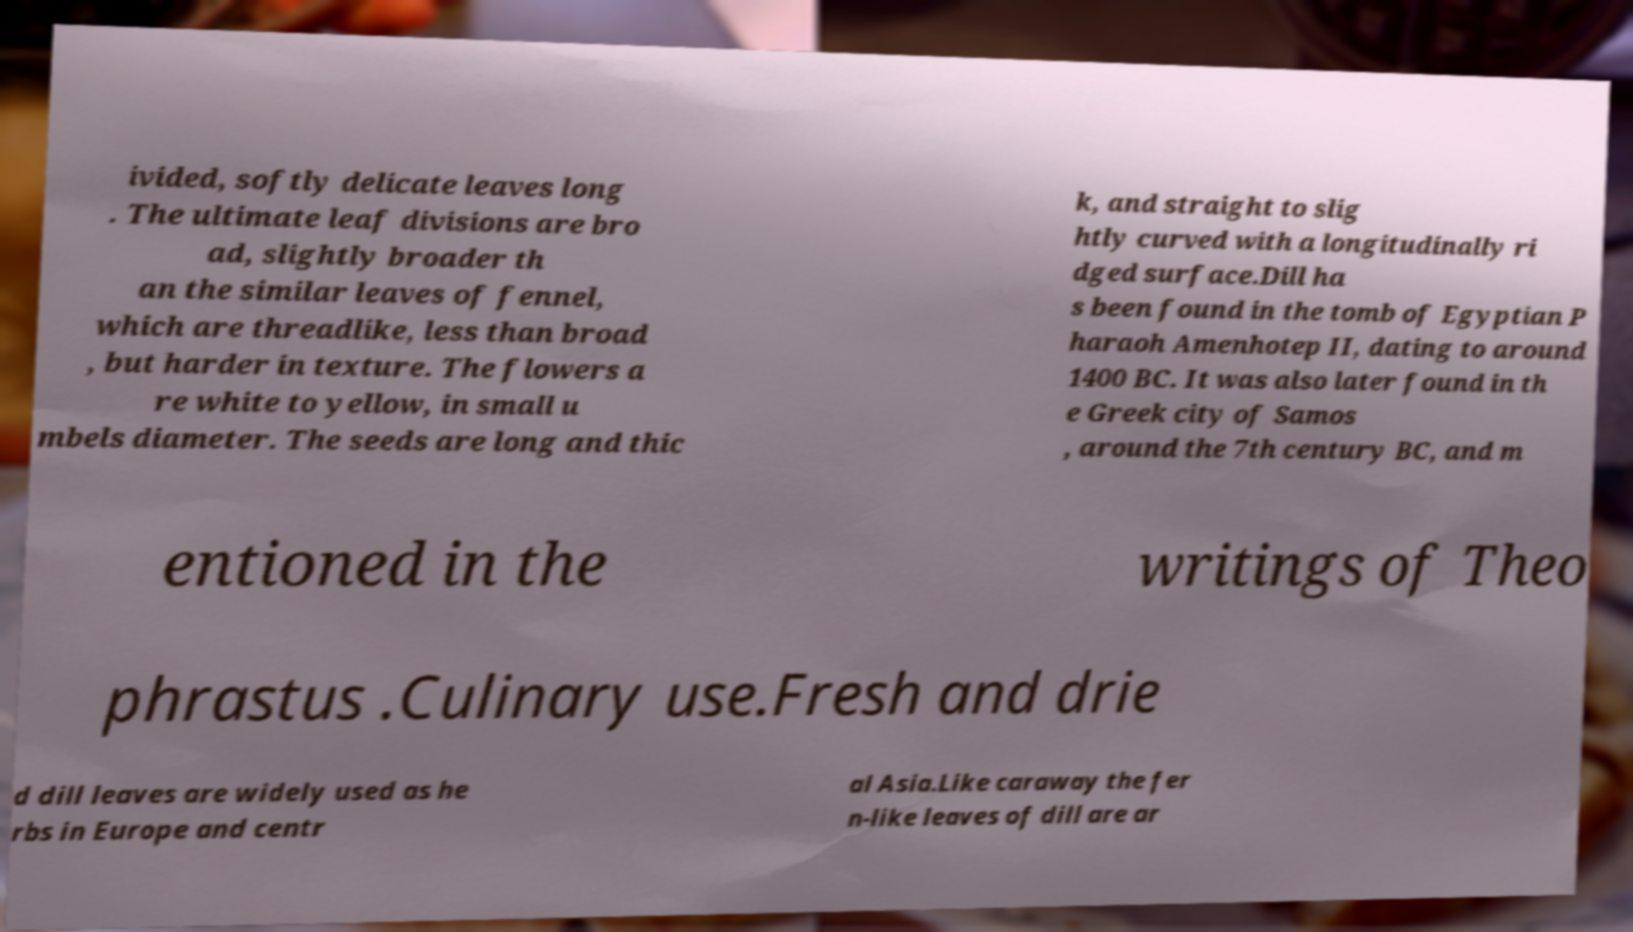Could you assist in decoding the text presented in this image and type it out clearly? ivided, softly delicate leaves long . The ultimate leaf divisions are bro ad, slightly broader th an the similar leaves of fennel, which are threadlike, less than broad , but harder in texture. The flowers a re white to yellow, in small u mbels diameter. The seeds are long and thic k, and straight to slig htly curved with a longitudinally ri dged surface.Dill ha s been found in the tomb of Egyptian P haraoh Amenhotep II, dating to around 1400 BC. It was also later found in th e Greek city of Samos , around the 7th century BC, and m entioned in the writings of Theo phrastus .Culinary use.Fresh and drie d dill leaves are widely used as he rbs in Europe and centr al Asia.Like caraway the fer n-like leaves of dill are ar 